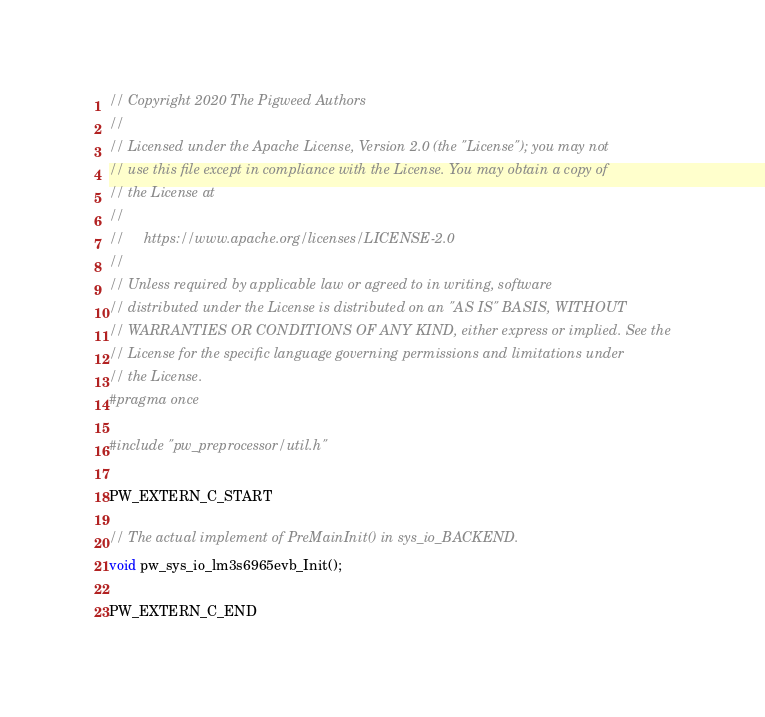Convert code to text. <code><loc_0><loc_0><loc_500><loc_500><_C_>// Copyright 2020 The Pigweed Authors
//
// Licensed under the Apache License, Version 2.0 (the "License"); you may not
// use this file except in compliance with the License. You may obtain a copy of
// the License at
//
//     https://www.apache.org/licenses/LICENSE-2.0
//
// Unless required by applicable law or agreed to in writing, software
// distributed under the License is distributed on an "AS IS" BASIS, WITHOUT
// WARRANTIES OR CONDITIONS OF ANY KIND, either express or implied. See the
// License for the specific language governing permissions and limitations under
// the License.
#pragma once

#include "pw_preprocessor/util.h"

PW_EXTERN_C_START

// The actual implement of PreMainInit() in sys_io_BACKEND.
void pw_sys_io_lm3s6965evb_Init();

PW_EXTERN_C_END
</code> 